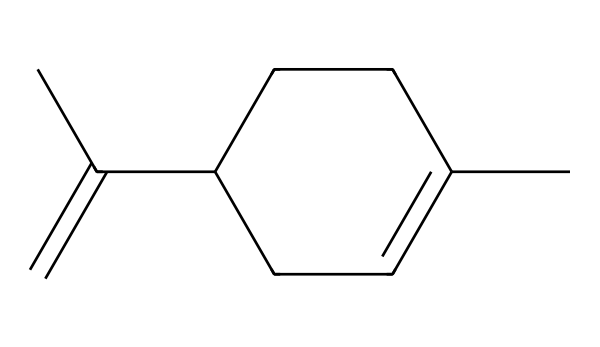What is the name of this chemical? The SMILES representation indicates a molecule typically recognized as limonene, which is characterized by its structure that includes multiple carbon atoms and prominent double bonds associated with citrus scents.
Answer: limonene How many carbon atoms are present in the structure? Counting the carbon atoms represented in the SMILES, we find there are ten carbon atoms (C). The basic carbon framework comprises a cyclic structure along with some branching, identifying it as a terpenoid.
Answer: ten Does this molecule have chiral centers? Analyzing the structure, there are asymmetric carbon atoms (chiral centers) present due to the arrangement of atoms around certain carbon atoms, where four different substituents are attached.
Answer: yes What is the degree of unsaturation in this compound? The degree of unsaturation can be calculated by analyzing the structure for double bonds and rings. In limonene, the presence of one cycloalkene and two double bonds contributes to a total degree of unsaturation of four.
Answer: four Which type of compound is limonene classified as? Based on its structure and functional groups, limonene is classified as a monoterpene, which specifically indicates it has a structure derived from two isoprene units and is typically known for its aromatic properties.
Answer: monoterpene What type of stereoisomers can limonene exhibit? Given the presence of chiral centers in limonene's structure, it can exist as two stereoisomers: (R)-limonene and (S)-limonene, each having distinct spatial arrangements contributing to the differences in scent.
Answer: two 